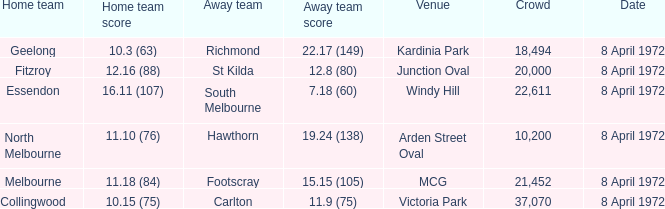Could you parse the entire table as a dict? {'header': ['Home team', 'Home team score', 'Away team', 'Away team score', 'Venue', 'Crowd', 'Date'], 'rows': [['Geelong', '10.3 (63)', 'Richmond', '22.17 (149)', 'Kardinia Park', '18,494', '8 April 1972'], ['Fitzroy', '12.16 (88)', 'St Kilda', '12.8 (80)', 'Junction Oval', '20,000', '8 April 1972'], ['Essendon', '16.11 (107)', 'South Melbourne', '7.18 (60)', 'Windy Hill', '22,611', '8 April 1972'], ['North Melbourne', '11.10 (76)', 'Hawthorn', '19.24 (138)', 'Arden Street Oval', '10,200', '8 April 1972'], ['Melbourne', '11.18 (84)', 'Footscray', '15.15 (105)', 'MCG', '21,452', '8 April 1972'], ['Collingwood', '10.15 (75)', 'Carlton', '11.9 (75)', 'Victoria Park', '37,070', '8 April 1972']]} What away team score is associated with the kardinia park venue? 22.17 (149). 